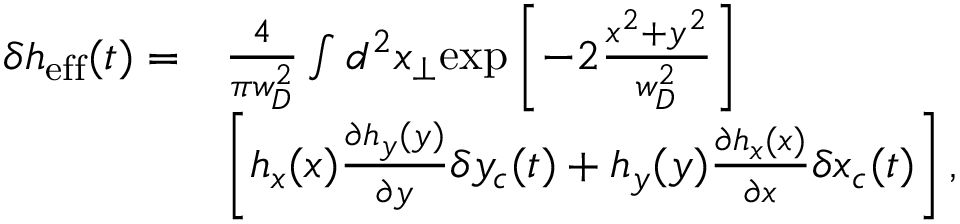Convert formula to latex. <formula><loc_0><loc_0><loc_500><loc_500>\begin{array} { r l } { \delta h _ { e f f } ( t ) = } & { \frac { 4 } { \pi w _ { D } ^ { 2 } } \int d ^ { 2 } x _ { \perp } e x p \left [ - 2 \frac { x ^ { 2 } + y ^ { 2 } } { w _ { D } ^ { 2 } } \right ] } \\ & { \left [ h _ { x } ( x ) \frac { \partial h _ { y } ( y ) } { \partial y } \delta y _ { c } ( t ) + h _ { y } ( y ) \frac { \partial h _ { x } ( x ) } { \partial x } \delta x _ { c } ( t ) \right ] , } \end{array}</formula> 